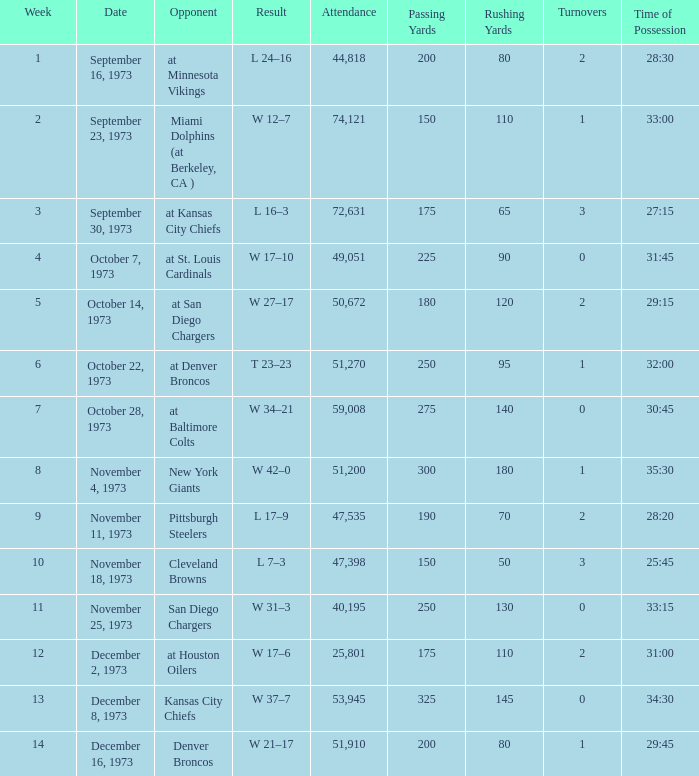What is the attendance for the game against the Kansas City Chiefs earlier than week 13? None. 